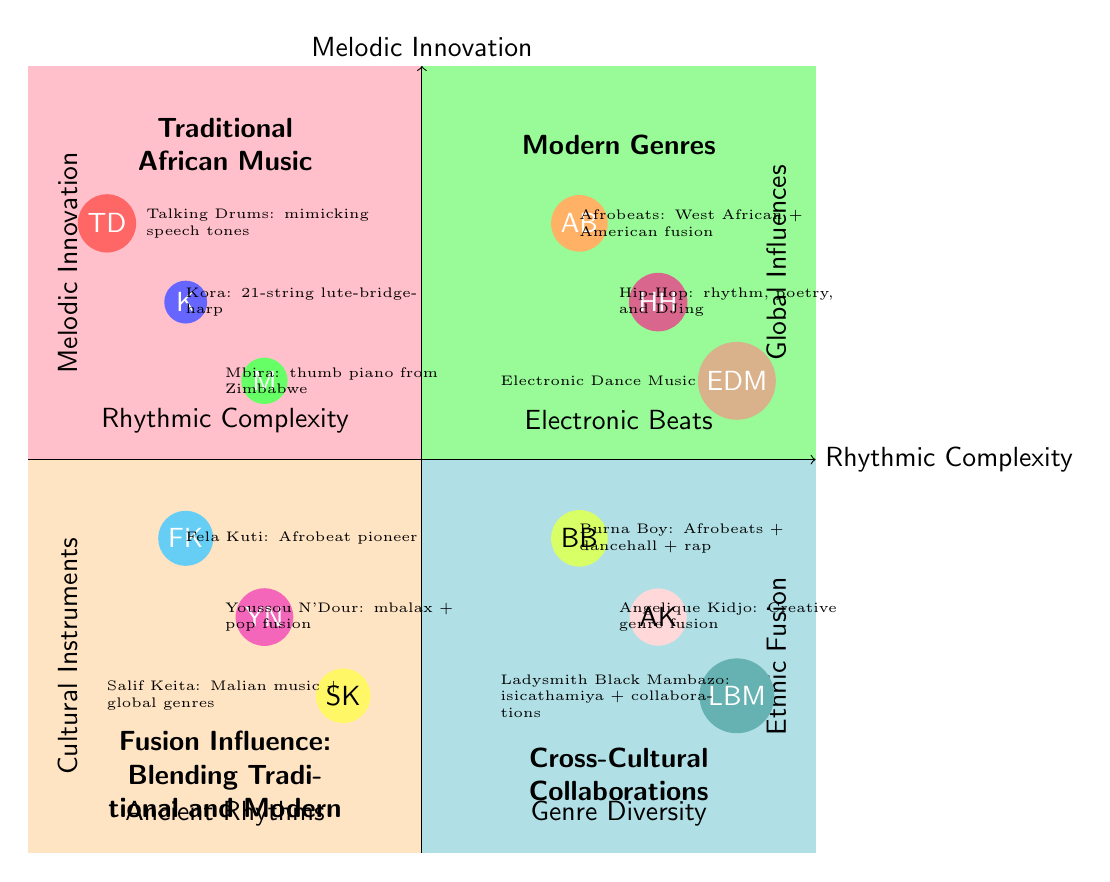What are the cultural instruments represented in the Traditional African Music quadrant? The Traditional African Music quadrant identifies the elements as Talking Drums, Kora, and Mbira. These instruments are listed in that specific section of the diagram.
Answer: Talking Drums, Kora, Mbira How many elements are present in the Modern Genres quadrant? The Modern Genres quadrant contains three elements: Afrobeats, Hip-Hop, and Electronic Dance Music. Counting these elements gives us a total of three.
Answer: 3 Which artist is positioned within the Fusion Influence quadrant and known as a pioneer of Afrobeat? The element in the Fusion Influence quadrant that represents the pioneer of Afrobeat is Fela Kuti. This information can be found directly within that specific quadrant.
Answer: Fela Kuti What genre combines African musical styles with American funk, jazz, and soul influences? Afrobeats is mentioned in the Modern Genres quadrant and is described as a genre that combines West African musical styles with American funk, jazz, and soul. This points directly to Afrobeats as the answer.
Answer: Afrobeats Which quadrant includes elements related to Cross-Cultural Collaborations? The quadrant titled Cross-Cultural Collaborations explicitly states its focus on genre diversity and ethnic fusion, thus providing its name as the answer.
Answer: Cross-Cultural Collaborations What kind of musical fusion does Angelique Kidjo represent? Angelique Kidjo is noted for her creative fusion of Afropop, Caribbean zouk, Congolese rumba, jazz, gospel, and Latin styles, indicating her broad musical fusion.
Answer: Creative genre fusion Which elements are aligned along the y-axis of the Fusion Influence quadrant? The y-axis of the Fusion Influence quadrant represents Melodic Innovation. The elements that align along this axis are Fela Kuti, Youssou N'Dour, and Salif Keita, indicating their contributions to melodic innovation.
Answer: Fela Kuti, Youssou N'Dour, Salif Keita How does Burna Boy's music genre vary according to the diagram? Burna Boy's genre is described in the Cross-Cultural Collaborations quadrant as a combination of Afrobeats, dancehall, reggae, and American rap, showcasing a diverse musical variation.
Answer: Afrobeats, dancehall, reggae, American rap Which quadrant features modern genres specifically associated with electronic music? The Modern Genres quadrant specifically highlights genres associated with electronic music, including Electronic Dance Music (EDM), making it the relevant segment for this query.
Answer: Modern Genres What is the significance of the axes in the Traditional African Music quadrant? In the Traditional African Music quadrant, the axes represent "Ancient Rhythms" and "Cultural Instruments," indicating the foundational aspects of the music discussed in this segment.
Answer: Ancient Rhythms, Cultural Instruments 